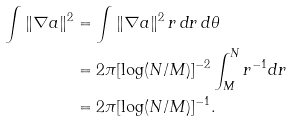Convert formula to latex. <formula><loc_0><loc_0><loc_500><loc_500>\int \| \nabla a \| ^ { 2 } & = \int \| \nabla a \| ^ { 2 } \, r \, d r \, d \theta \\ & = 2 \pi [ \log ( N / M ) ] ^ { - 2 } \int _ { M } ^ { N } r ^ { - 1 } d r \\ & = 2 \pi [ \log ( N / M ) ] ^ { - 1 } .</formula> 